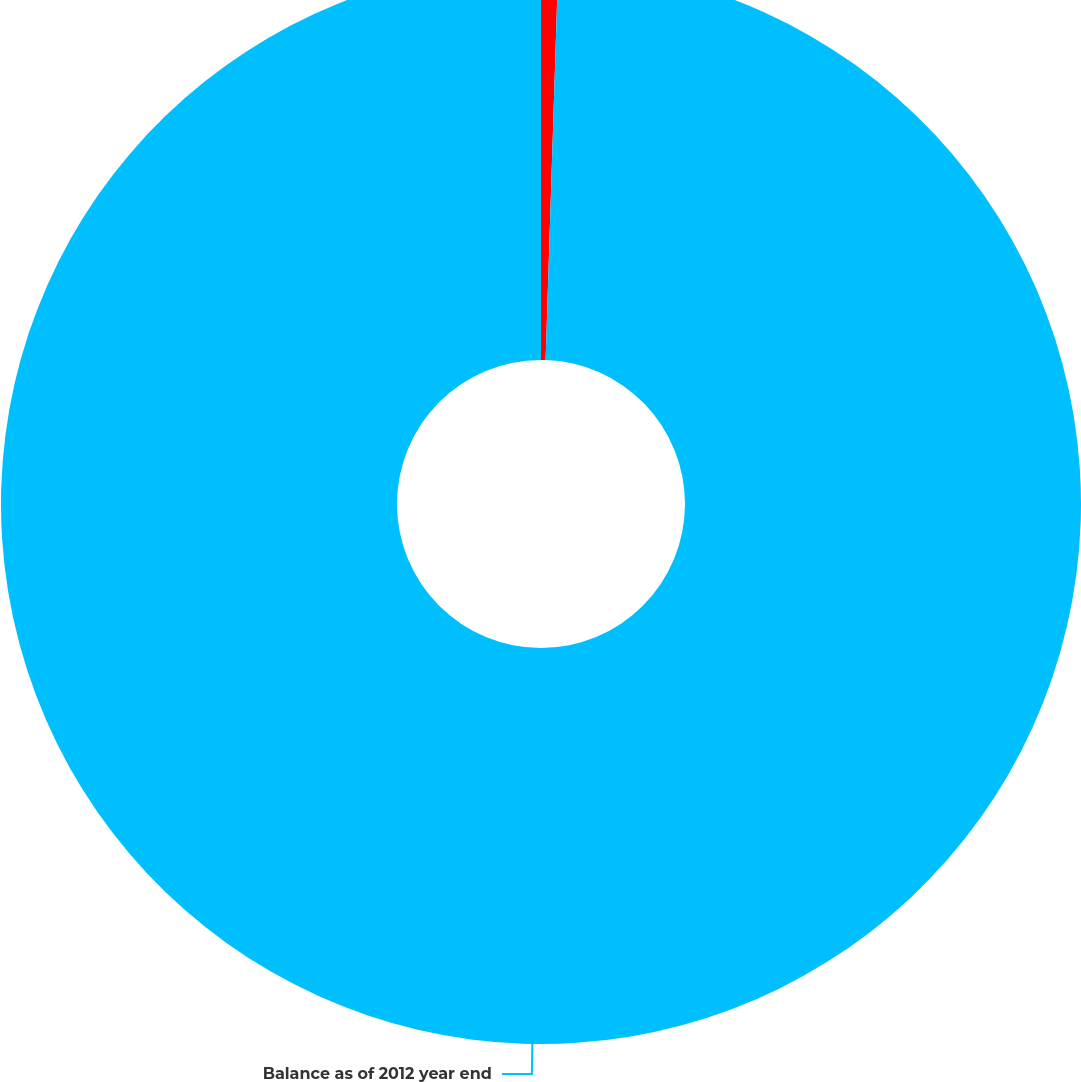Convert chart. <chart><loc_0><loc_0><loc_500><loc_500><pie_chart><fcel>Realized gains on assets sold<fcel>Balance as of 2012 year end<nl><fcel>0.51%<fcel>99.49%<nl></chart> 